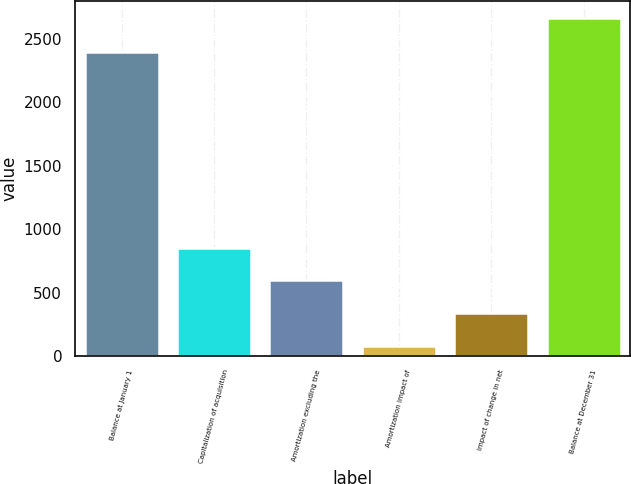Convert chart. <chart><loc_0><loc_0><loc_500><loc_500><bar_chart><fcel>Balance at January 1<fcel>Capitalization of acquisition<fcel>Amortization excluding the<fcel>Amortization impact of<fcel>Impact of change in net<fcel>Balance at December 31<nl><fcel>2399<fcel>853.5<fcel>595<fcel>78<fcel>336.5<fcel>2663<nl></chart> 